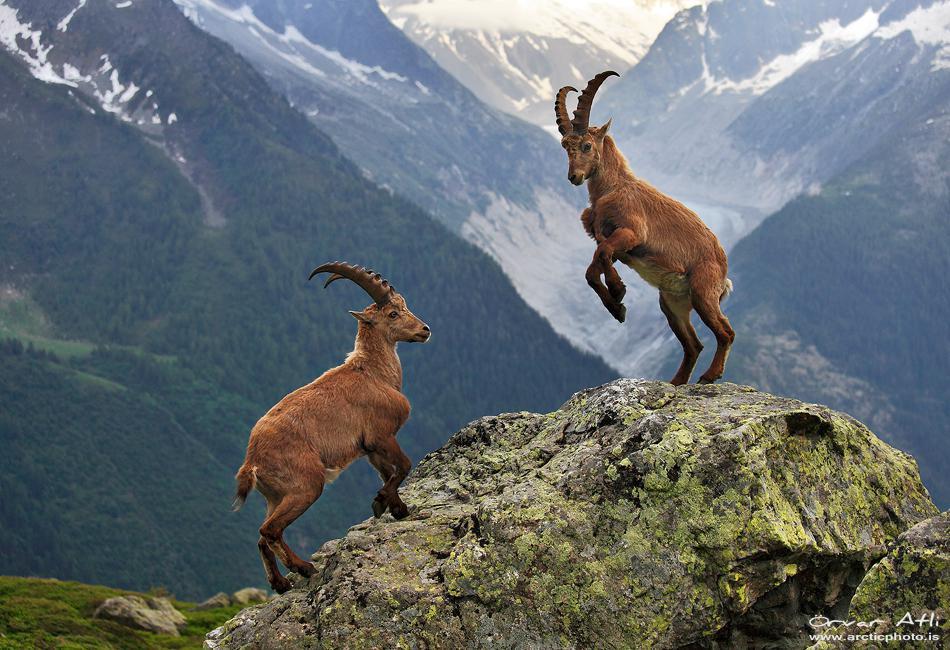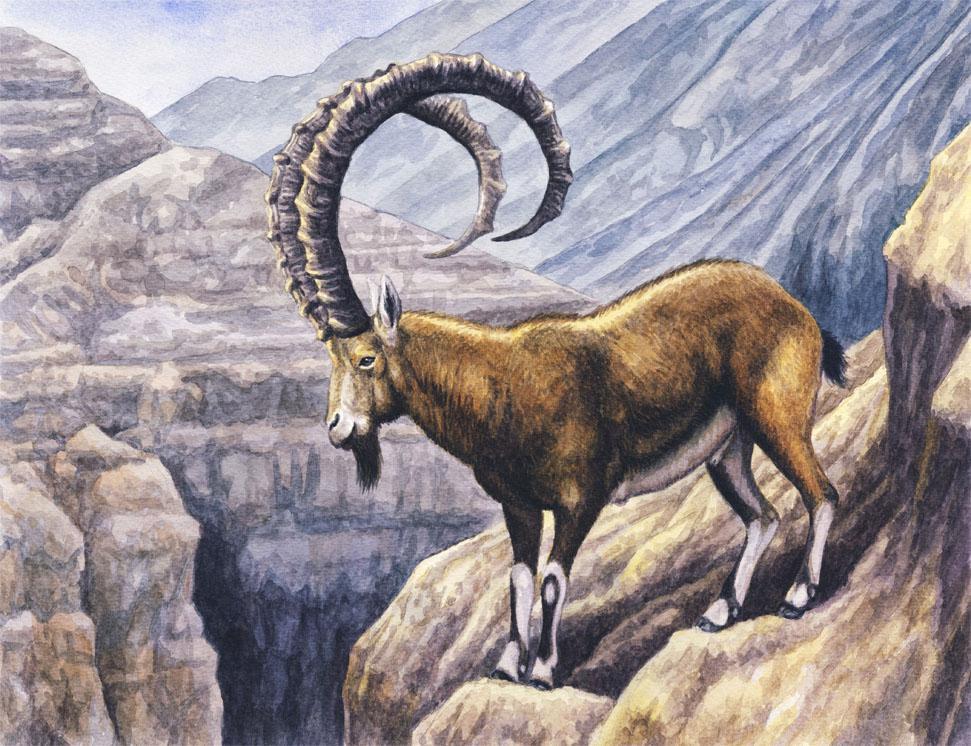The first image is the image on the left, the second image is the image on the right. For the images shown, is this caption "An image includes a rearing horned animal, with both its front legs high off the ground." true? Answer yes or no. Yes. The first image is the image on the left, the second image is the image on the right. Analyze the images presented: Is the assertion "Two animals are butting heads in the image on the right." valid? Answer yes or no. No. 